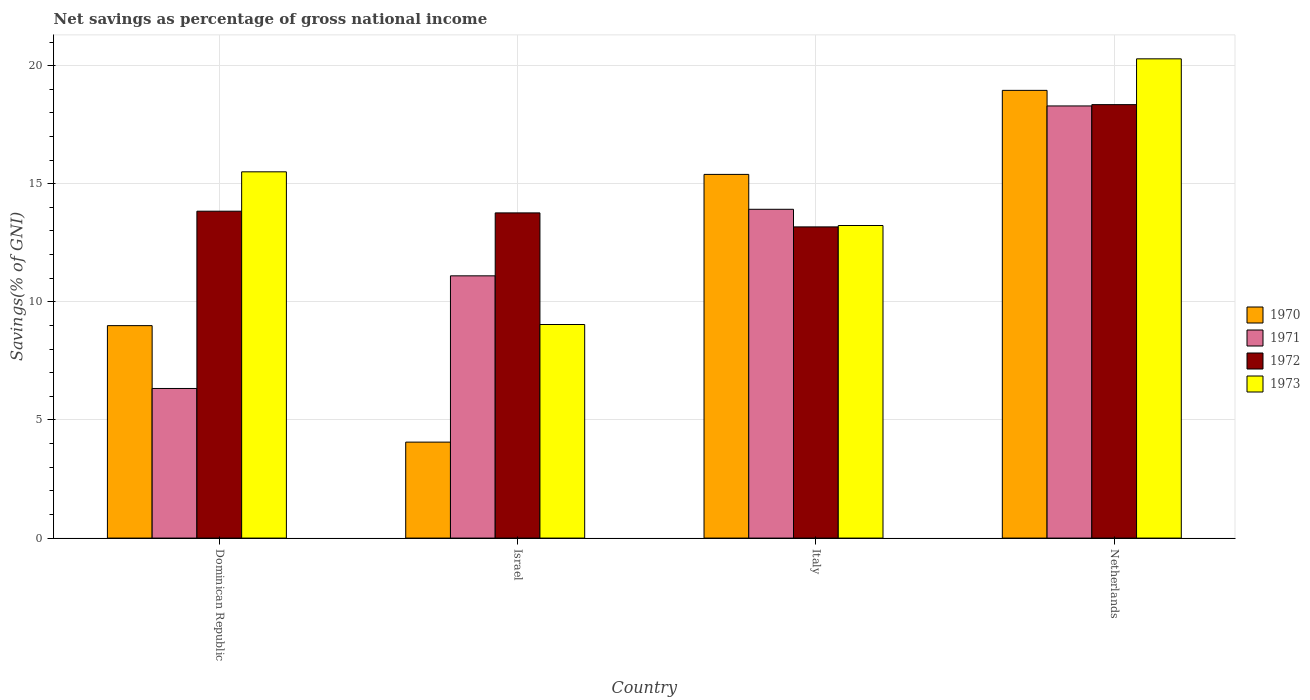How many different coloured bars are there?
Offer a terse response. 4. Are the number of bars per tick equal to the number of legend labels?
Your response must be concise. Yes. Are the number of bars on each tick of the X-axis equal?
Your answer should be very brief. Yes. How many bars are there on the 3rd tick from the left?
Provide a succinct answer. 4. What is the label of the 4th group of bars from the left?
Ensure brevity in your answer.  Netherlands. In how many cases, is the number of bars for a given country not equal to the number of legend labels?
Your response must be concise. 0. What is the total savings in 1972 in Dominican Republic?
Your answer should be compact. 13.84. Across all countries, what is the maximum total savings in 1971?
Ensure brevity in your answer.  18.29. Across all countries, what is the minimum total savings in 1971?
Provide a succinct answer. 6.33. In which country was the total savings in 1973 minimum?
Provide a short and direct response. Israel. What is the total total savings in 1972 in the graph?
Your answer should be compact. 59.13. What is the difference between the total savings in 1973 in Dominican Republic and that in Israel?
Offer a terse response. 6.46. What is the difference between the total savings in 1972 in Italy and the total savings in 1973 in Israel?
Your answer should be very brief. 4.13. What is the average total savings in 1973 per country?
Provide a succinct answer. 14.52. What is the difference between the total savings of/in 1973 and total savings of/in 1972 in Italy?
Offer a terse response. 0.06. What is the ratio of the total savings in 1971 in Dominican Republic to that in Netherlands?
Ensure brevity in your answer.  0.35. What is the difference between the highest and the second highest total savings in 1970?
Ensure brevity in your answer.  -9.96. What is the difference between the highest and the lowest total savings in 1973?
Offer a very short reply. 11.25. In how many countries, is the total savings in 1973 greater than the average total savings in 1973 taken over all countries?
Your answer should be compact. 2. Is the sum of the total savings in 1972 in Dominican Republic and Israel greater than the maximum total savings in 1970 across all countries?
Provide a succinct answer. Yes. What does the 2nd bar from the right in Dominican Republic represents?
Offer a very short reply. 1972. How many bars are there?
Provide a short and direct response. 16. Does the graph contain any zero values?
Offer a terse response. No. Does the graph contain grids?
Your answer should be very brief. Yes. Where does the legend appear in the graph?
Your response must be concise. Center right. How are the legend labels stacked?
Provide a short and direct response. Vertical. What is the title of the graph?
Keep it short and to the point. Net savings as percentage of gross national income. Does "1992" appear as one of the legend labels in the graph?
Keep it short and to the point. No. What is the label or title of the Y-axis?
Ensure brevity in your answer.  Savings(% of GNI). What is the Savings(% of GNI) of 1970 in Dominican Republic?
Make the answer very short. 8.99. What is the Savings(% of GNI) of 1971 in Dominican Republic?
Your answer should be compact. 6.33. What is the Savings(% of GNI) of 1972 in Dominican Republic?
Make the answer very short. 13.84. What is the Savings(% of GNI) in 1973 in Dominican Republic?
Offer a terse response. 15.5. What is the Savings(% of GNI) of 1970 in Israel?
Your answer should be very brief. 4.06. What is the Savings(% of GNI) in 1971 in Israel?
Your answer should be very brief. 11.1. What is the Savings(% of GNI) in 1972 in Israel?
Provide a short and direct response. 13.77. What is the Savings(% of GNI) of 1973 in Israel?
Offer a very short reply. 9.04. What is the Savings(% of GNI) in 1970 in Italy?
Keep it short and to the point. 15.4. What is the Savings(% of GNI) of 1971 in Italy?
Ensure brevity in your answer.  13.92. What is the Savings(% of GNI) of 1972 in Italy?
Your response must be concise. 13.17. What is the Savings(% of GNI) in 1973 in Italy?
Ensure brevity in your answer.  13.23. What is the Savings(% of GNI) in 1970 in Netherlands?
Provide a succinct answer. 18.95. What is the Savings(% of GNI) in 1971 in Netherlands?
Make the answer very short. 18.29. What is the Savings(% of GNI) in 1972 in Netherlands?
Keep it short and to the point. 18.35. What is the Savings(% of GNI) in 1973 in Netherlands?
Provide a short and direct response. 20.29. Across all countries, what is the maximum Savings(% of GNI) of 1970?
Ensure brevity in your answer.  18.95. Across all countries, what is the maximum Savings(% of GNI) of 1971?
Offer a terse response. 18.29. Across all countries, what is the maximum Savings(% of GNI) in 1972?
Offer a very short reply. 18.35. Across all countries, what is the maximum Savings(% of GNI) of 1973?
Offer a very short reply. 20.29. Across all countries, what is the minimum Savings(% of GNI) of 1970?
Offer a terse response. 4.06. Across all countries, what is the minimum Savings(% of GNI) in 1971?
Your response must be concise. 6.33. Across all countries, what is the minimum Savings(% of GNI) of 1972?
Your answer should be compact. 13.17. Across all countries, what is the minimum Savings(% of GNI) of 1973?
Offer a terse response. 9.04. What is the total Savings(% of GNI) in 1970 in the graph?
Make the answer very short. 47.41. What is the total Savings(% of GNI) in 1971 in the graph?
Give a very brief answer. 49.65. What is the total Savings(% of GNI) of 1972 in the graph?
Keep it short and to the point. 59.13. What is the total Savings(% of GNI) of 1973 in the graph?
Ensure brevity in your answer.  58.07. What is the difference between the Savings(% of GNI) in 1970 in Dominican Republic and that in Israel?
Your answer should be compact. 4.93. What is the difference between the Savings(% of GNI) of 1971 in Dominican Republic and that in Israel?
Ensure brevity in your answer.  -4.77. What is the difference between the Savings(% of GNI) of 1972 in Dominican Republic and that in Israel?
Your answer should be compact. 0.07. What is the difference between the Savings(% of GNI) in 1973 in Dominican Republic and that in Israel?
Offer a terse response. 6.46. What is the difference between the Savings(% of GNI) in 1970 in Dominican Republic and that in Italy?
Make the answer very short. -6.4. What is the difference between the Savings(% of GNI) in 1971 in Dominican Republic and that in Italy?
Your response must be concise. -7.59. What is the difference between the Savings(% of GNI) in 1972 in Dominican Republic and that in Italy?
Your answer should be compact. 0.66. What is the difference between the Savings(% of GNI) in 1973 in Dominican Republic and that in Italy?
Give a very brief answer. 2.27. What is the difference between the Savings(% of GNI) of 1970 in Dominican Republic and that in Netherlands?
Your answer should be very brief. -9.96. What is the difference between the Savings(% of GNI) in 1971 in Dominican Republic and that in Netherlands?
Ensure brevity in your answer.  -11.96. What is the difference between the Savings(% of GNI) in 1972 in Dominican Republic and that in Netherlands?
Make the answer very short. -4.51. What is the difference between the Savings(% of GNI) of 1973 in Dominican Republic and that in Netherlands?
Offer a very short reply. -4.78. What is the difference between the Savings(% of GNI) in 1970 in Israel and that in Italy?
Offer a terse response. -11.33. What is the difference between the Savings(% of GNI) of 1971 in Israel and that in Italy?
Offer a very short reply. -2.82. What is the difference between the Savings(% of GNI) in 1972 in Israel and that in Italy?
Keep it short and to the point. 0.59. What is the difference between the Savings(% of GNI) in 1973 in Israel and that in Italy?
Provide a succinct answer. -4.19. What is the difference between the Savings(% of GNI) in 1970 in Israel and that in Netherlands?
Give a very brief answer. -14.89. What is the difference between the Savings(% of GNI) of 1971 in Israel and that in Netherlands?
Your answer should be very brief. -7.19. What is the difference between the Savings(% of GNI) of 1972 in Israel and that in Netherlands?
Offer a terse response. -4.58. What is the difference between the Savings(% of GNI) in 1973 in Israel and that in Netherlands?
Provide a succinct answer. -11.25. What is the difference between the Savings(% of GNI) in 1970 in Italy and that in Netherlands?
Provide a succinct answer. -3.56. What is the difference between the Savings(% of GNI) of 1971 in Italy and that in Netherlands?
Provide a short and direct response. -4.37. What is the difference between the Savings(% of GNI) of 1972 in Italy and that in Netherlands?
Provide a short and direct response. -5.18. What is the difference between the Savings(% of GNI) of 1973 in Italy and that in Netherlands?
Keep it short and to the point. -7.06. What is the difference between the Savings(% of GNI) of 1970 in Dominican Republic and the Savings(% of GNI) of 1971 in Israel?
Offer a very short reply. -2.11. What is the difference between the Savings(% of GNI) of 1970 in Dominican Republic and the Savings(% of GNI) of 1972 in Israel?
Keep it short and to the point. -4.77. What is the difference between the Savings(% of GNI) of 1970 in Dominican Republic and the Savings(% of GNI) of 1973 in Israel?
Your response must be concise. -0.05. What is the difference between the Savings(% of GNI) of 1971 in Dominican Republic and the Savings(% of GNI) of 1972 in Israel?
Provide a succinct answer. -7.43. What is the difference between the Savings(% of GNI) of 1971 in Dominican Republic and the Savings(% of GNI) of 1973 in Israel?
Keep it short and to the point. -2.71. What is the difference between the Savings(% of GNI) in 1972 in Dominican Republic and the Savings(% of GNI) in 1973 in Israel?
Keep it short and to the point. 4.8. What is the difference between the Savings(% of GNI) of 1970 in Dominican Republic and the Savings(% of GNI) of 1971 in Italy?
Offer a terse response. -4.93. What is the difference between the Savings(% of GNI) in 1970 in Dominican Republic and the Savings(% of GNI) in 1972 in Italy?
Make the answer very short. -4.18. What is the difference between the Savings(% of GNI) in 1970 in Dominican Republic and the Savings(% of GNI) in 1973 in Italy?
Give a very brief answer. -4.24. What is the difference between the Savings(% of GNI) of 1971 in Dominican Republic and the Savings(% of GNI) of 1972 in Italy?
Offer a terse response. -6.84. What is the difference between the Savings(% of GNI) of 1971 in Dominican Republic and the Savings(% of GNI) of 1973 in Italy?
Offer a very short reply. -6.9. What is the difference between the Savings(% of GNI) of 1972 in Dominican Republic and the Savings(% of GNI) of 1973 in Italy?
Your answer should be very brief. 0.61. What is the difference between the Savings(% of GNI) of 1970 in Dominican Republic and the Savings(% of GNI) of 1971 in Netherlands?
Provide a succinct answer. -9.3. What is the difference between the Savings(% of GNI) of 1970 in Dominican Republic and the Savings(% of GNI) of 1972 in Netherlands?
Offer a terse response. -9.36. What is the difference between the Savings(% of GNI) in 1970 in Dominican Republic and the Savings(% of GNI) in 1973 in Netherlands?
Your answer should be compact. -11.29. What is the difference between the Savings(% of GNI) of 1971 in Dominican Republic and the Savings(% of GNI) of 1972 in Netherlands?
Keep it short and to the point. -12.02. What is the difference between the Savings(% of GNI) of 1971 in Dominican Republic and the Savings(% of GNI) of 1973 in Netherlands?
Provide a succinct answer. -13.95. What is the difference between the Savings(% of GNI) of 1972 in Dominican Republic and the Savings(% of GNI) of 1973 in Netherlands?
Provide a succinct answer. -6.45. What is the difference between the Savings(% of GNI) of 1970 in Israel and the Savings(% of GNI) of 1971 in Italy?
Offer a terse response. -9.86. What is the difference between the Savings(% of GNI) of 1970 in Israel and the Savings(% of GNI) of 1972 in Italy?
Your answer should be compact. -9.11. What is the difference between the Savings(% of GNI) of 1970 in Israel and the Savings(% of GNI) of 1973 in Italy?
Provide a succinct answer. -9.17. What is the difference between the Savings(% of GNI) in 1971 in Israel and the Savings(% of GNI) in 1972 in Italy?
Ensure brevity in your answer.  -2.07. What is the difference between the Savings(% of GNI) of 1971 in Israel and the Savings(% of GNI) of 1973 in Italy?
Provide a short and direct response. -2.13. What is the difference between the Savings(% of GNI) in 1972 in Israel and the Savings(% of GNI) in 1973 in Italy?
Offer a very short reply. 0.53. What is the difference between the Savings(% of GNI) of 1970 in Israel and the Savings(% of GNI) of 1971 in Netherlands?
Your answer should be compact. -14.23. What is the difference between the Savings(% of GNI) of 1970 in Israel and the Savings(% of GNI) of 1972 in Netherlands?
Your answer should be very brief. -14.29. What is the difference between the Savings(% of GNI) of 1970 in Israel and the Savings(% of GNI) of 1973 in Netherlands?
Provide a succinct answer. -16.22. What is the difference between the Savings(% of GNI) in 1971 in Israel and the Savings(% of GNI) in 1972 in Netherlands?
Provide a succinct answer. -7.25. What is the difference between the Savings(% of GNI) in 1971 in Israel and the Savings(% of GNI) in 1973 in Netherlands?
Offer a terse response. -9.19. What is the difference between the Savings(% of GNI) in 1972 in Israel and the Savings(% of GNI) in 1973 in Netherlands?
Your answer should be compact. -6.52. What is the difference between the Savings(% of GNI) of 1970 in Italy and the Savings(% of GNI) of 1971 in Netherlands?
Offer a very short reply. -2.9. What is the difference between the Savings(% of GNI) of 1970 in Italy and the Savings(% of GNI) of 1972 in Netherlands?
Provide a short and direct response. -2.95. What is the difference between the Savings(% of GNI) of 1970 in Italy and the Savings(% of GNI) of 1973 in Netherlands?
Provide a succinct answer. -4.89. What is the difference between the Savings(% of GNI) in 1971 in Italy and the Savings(% of GNI) in 1972 in Netherlands?
Keep it short and to the point. -4.43. What is the difference between the Savings(% of GNI) of 1971 in Italy and the Savings(% of GNI) of 1973 in Netherlands?
Provide a succinct answer. -6.37. What is the difference between the Savings(% of GNI) of 1972 in Italy and the Savings(% of GNI) of 1973 in Netherlands?
Provide a succinct answer. -7.11. What is the average Savings(% of GNI) of 1970 per country?
Your response must be concise. 11.85. What is the average Savings(% of GNI) in 1971 per country?
Your answer should be compact. 12.41. What is the average Savings(% of GNI) of 1972 per country?
Your answer should be very brief. 14.78. What is the average Savings(% of GNI) of 1973 per country?
Provide a succinct answer. 14.52. What is the difference between the Savings(% of GNI) in 1970 and Savings(% of GNI) in 1971 in Dominican Republic?
Offer a terse response. 2.66. What is the difference between the Savings(% of GNI) in 1970 and Savings(% of GNI) in 1972 in Dominican Republic?
Your answer should be very brief. -4.84. What is the difference between the Savings(% of GNI) of 1970 and Savings(% of GNI) of 1973 in Dominican Republic?
Give a very brief answer. -6.51. What is the difference between the Savings(% of GNI) of 1971 and Savings(% of GNI) of 1972 in Dominican Republic?
Your answer should be compact. -7.5. What is the difference between the Savings(% of GNI) in 1971 and Savings(% of GNI) in 1973 in Dominican Republic?
Your response must be concise. -9.17. What is the difference between the Savings(% of GNI) in 1972 and Savings(% of GNI) in 1973 in Dominican Republic?
Make the answer very short. -1.67. What is the difference between the Savings(% of GNI) of 1970 and Savings(% of GNI) of 1971 in Israel?
Give a very brief answer. -7.04. What is the difference between the Savings(% of GNI) of 1970 and Savings(% of GNI) of 1972 in Israel?
Your answer should be very brief. -9.7. What is the difference between the Savings(% of GNI) in 1970 and Savings(% of GNI) in 1973 in Israel?
Make the answer very short. -4.98. What is the difference between the Savings(% of GNI) of 1971 and Savings(% of GNI) of 1972 in Israel?
Your response must be concise. -2.66. What is the difference between the Savings(% of GNI) in 1971 and Savings(% of GNI) in 1973 in Israel?
Your answer should be very brief. 2.06. What is the difference between the Savings(% of GNI) in 1972 and Savings(% of GNI) in 1973 in Israel?
Your answer should be very brief. 4.73. What is the difference between the Savings(% of GNI) of 1970 and Savings(% of GNI) of 1971 in Italy?
Make the answer very short. 1.48. What is the difference between the Savings(% of GNI) of 1970 and Savings(% of GNI) of 1972 in Italy?
Give a very brief answer. 2.22. What is the difference between the Savings(% of GNI) of 1970 and Savings(% of GNI) of 1973 in Italy?
Offer a terse response. 2.16. What is the difference between the Savings(% of GNI) in 1971 and Savings(% of GNI) in 1972 in Italy?
Offer a very short reply. 0.75. What is the difference between the Savings(% of GNI) of 1971 and Savings(% of GNI) of 1973 in Italy?
Provide a succinct answer. 0.69. What is the difference between the Savings(% of GNI) of 1972 and Savings(% of GNI) of 1973 in Italy?
Provide a succinct answer. -0.06. What is the difference between the Savings(% of GNI) of 1970 and Savings(% of GNI) of 1971 in Netherlands?
Provide a succinct answer. 0.66. What is the difference between the Savings(% of GNI) of 1970 and Savings(% of GNI) of 1972 in Netherlands?
Give a very brief answer. 0.6. What is the difference between the Savings(% of GNI) of 1970 and Savings(% of GNI) of 1973 in Netherlands?
Your response must be concise. -1.33. What is the difference between the Savings(% of GNI) in 1971 and Savings(% of GNI) in 1972 in Netherlands?
Ensure brevity in your answer.  -0.06. What is the difference between the Savings(% of GNI) in 1971 and Savings(% of GNI) in 1973 in Netherlands?
Your answer should be compact. -1.99. What is the difference between the Savings(% of GNI) of 1972 and Savings(% of GNI) of 1973 in Netherlands?
Give a very brief answer. -1.94. What is the ratio of the Savings(% of GNI) in 1970 in Dominican Republic to that in Israel?
Your response must be concise. 2.21. What is the ratio of the Savings(% of GNI) in 1971 in Dominican Republic to that in Israel?
Your response must be concise. 0.57. What is the ratio of the Savings(% of GNI) in 1972 in Dominican Republic to that in Israel?
Provide a succinct answer. 1.01. What is the ratio of the Savings(% of GNI) of 1973 in Dominican Republic to that in Israel?
Your response must be concise. 1.71. What is the ratio of the Savings(% of GNI) of 1970 in Dominican Republic to that in Italy?
Your answer should be very brief. 0.58. What is the ratio of the Savings(% of GNI) in 1971 in Dominican Republic to that in Italy?
Your response must be concise. 0.46. What is the ratio of the Savings(% of GNI) of 1972 in Dominican Republic to that in Italy?
Ensure brevity in your answer.  1.05. What is the ratio of the Savings(% of GNI) of 1973 in Dominican Republic to that in Italy?
Your answer should be very brief. 1.17. What is the ratio of the Savings(% of GNI) in 1970 in Dominican Republic to that in Netherlands?
Your answer should be compact. 0.47. What is the ratio of the Savings(% of GNI) of 1971 in Dominican Republic to that in Netherlands?
Your answer should be compact. 0.35. What is the ratio of the Savings(% of GNI) in 1972 in Dominican Republic to that in Netherlands?
Provide a short and direct response. 0.75. What is the ratio of the Savings(% of GNI) in 1973 in Dominican Republic to that in Netherlands?
Provide a short and direct response. 0.76. What is the ratio of the Savings(% of GNI) of 1970 in Israel to that in Italy?
Your response must be concise. 0.26. What is the ratio of the Savings(% of GNI) in 1971 in Israel to that in Italy?
Your answer should be very brief. 0.8. What is the ratio of the Savings(% of GNI) in 1972 in Israel to that in Italy?
Your answer should be compact. 1.04. What is the ratio of the Savings(% of GNI) of 1973 in Israel to that in Italy?
Keep it short and to the point. 0.68. What is the ratio of the Savings(% of GNI) in 1970 in Israel to that in Netherlands?
Ensure brevity in your answer.  0.21. What is the ratio of the Savings(% of GNI) of 1971 in Israel to that in Netherlands?
Keep it short and to the point. 0.61. What is the ratio of the Savings(% of GNI) in 1972 in Israel to that in Netherlands?
Give a very brief answer. 0.75. What is the ratio of the Savings(% of GNI) in 1973 in Israel to that in Netherlands?
Keep it short and to the point. 0.45. What is the ratio of the Savings(% of GNI) of 1970 in Italy to that in Netherlands?
Offer a very short reply. 0.81. What is the ratio of the Savings(% of GNI) in 1971 in Italy to that in Netherlands?
Give a very brief answer. 0.76. What is the ratio of the Savings(% of GNI) in 1972 in Italy to that in Netherlands?
Your response must be concise. 0.72. What is the ratio of the Savings(% of GNI) in 1973 in Italy to that in Netherlands?
Offer a very short reply. 0.65. What is the difference between the highest and the second highest Savings(% of GNI) in 1970?
Keep it short and to the point. 3.56. What is the difference between the highest and the second highest Savings(% of GNI) of 1971?
Your answer should be compact. 4.37. What is the difference between the highest and the second highest Savings(% of GNI) in 1972?
Provide a short and direct response. 4.51. What is the difference between the highest and the second highest Savings(% of GNI) in 1973?
Keep it short and to the point. 4.78. What is the difference between the highest and the lowest Savings(% of GNI) in 1970?
Your answer should be compact. 14.89. What is the difference between the highest and the lowest Savings(% of GNI) in 1971?
Offer a very short reply. 11.96. What is the difference between the highest and the lowest Savings(% of GNI) of 1972?
Make the answer very short. 5.18. What is the difference between the highest and the lowest Savings(% of GNI) of 1973?
Your answer should be compact. 11.25. 